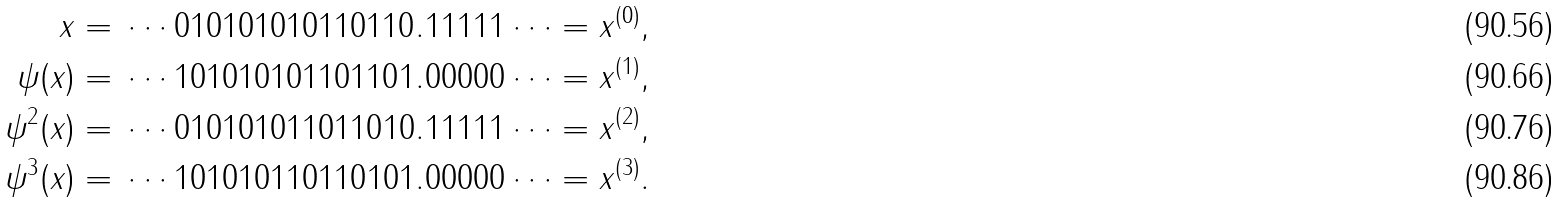<formula> <loc_0><loc_0><loc_500><loc_500>x = \, \cdots 0 1 0 1 0 1 0 1 { 0 1 1 0 1 1 0 } . 1 1 1 1 1 \cdots & = x ^ { ( 0 ) } , \\ \psi ( x ) = \, \cdots 1 0 1 0 1 0 1 { 0 1 1 0 1 1 0 } 1 . 0 0 0 0 0 \cdots & = x ^ { ( 1 ) } , \\ \psi ^ { 2 } ( x ) = \, \cdots 0 1 0 1 0 1 { 0 1 1 0 1 1 0 } 1 0 . 1 1 1 1 1 \cdots & = x ^ { ( 2 ) } , \\ \psi ^ { 3 } ( x ) = \, \cdots 1 0 1 0 1 { 0 1 1 0 1 1 0 } 1 0 1 . 0 0 0 0 0 \cdots & = x ^ { ( 3 ) } .</formula> 